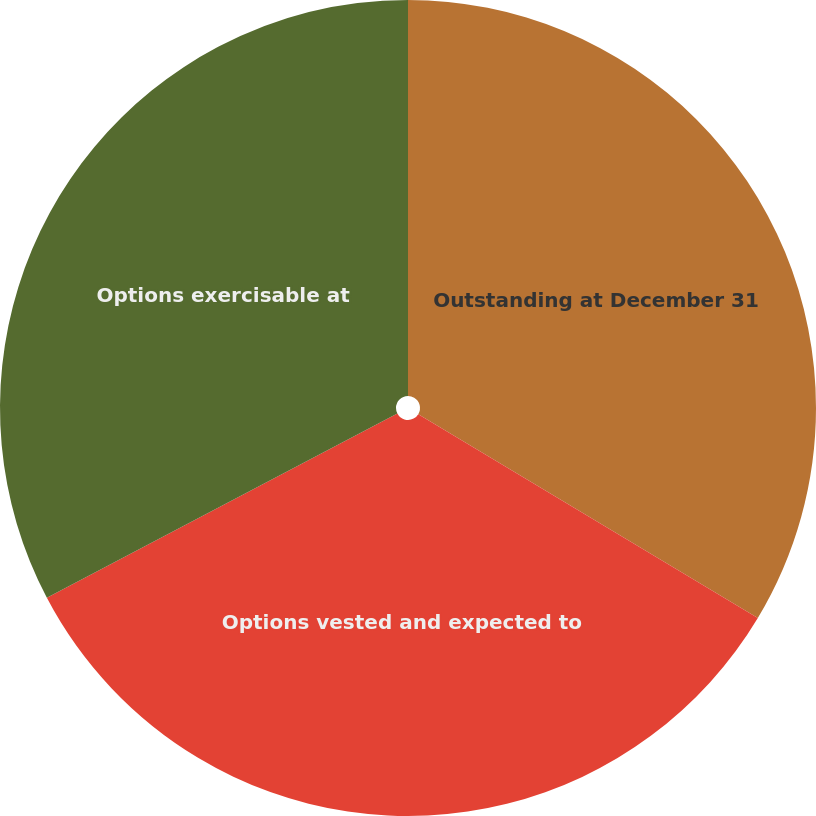Convert chart. <chart><loc_0><loc_0><loc_500><loc_500><pie_chart><fcel>Outstanding at December 31<fcel>Options vested and expected to<fcel>Options exercisable at<nl><fcel>33.6%<fcel>33.69%<fcel>32.7%<nl></chart> 